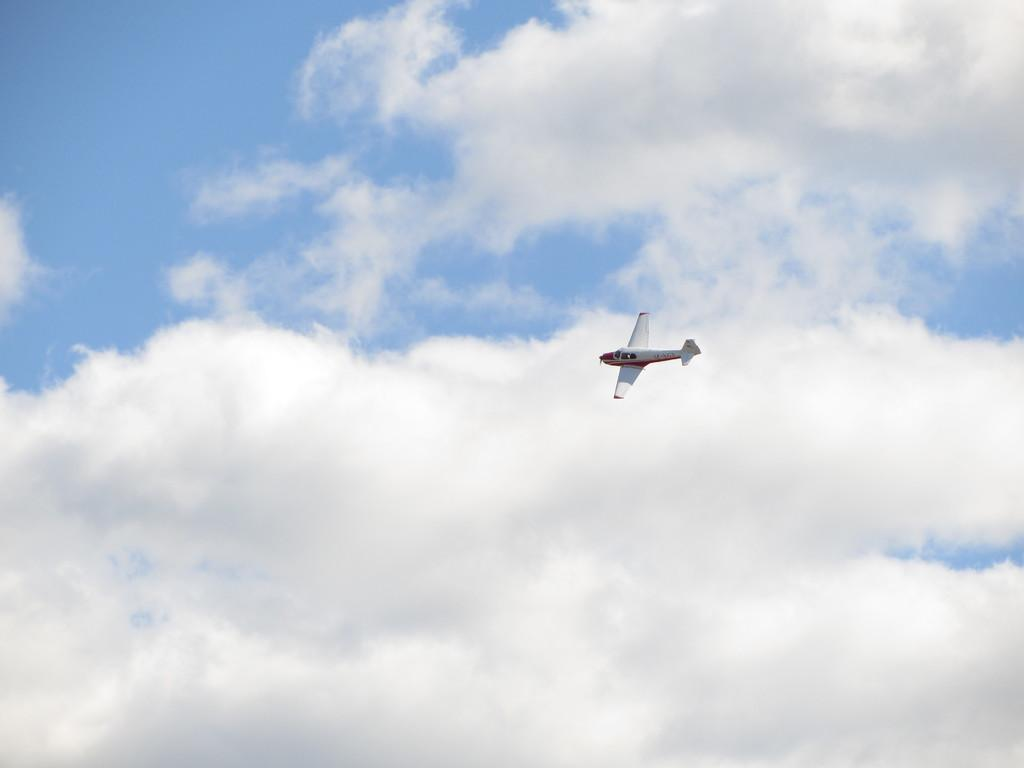Where was the image taken? The image is clicked outside. What can be seen in the sky in the image? There is an airplane flying in the sky. What is visible in the background of the image? The sky is visible in the background of the image. What is the condition of the sky in the image? Clouds are present in the sky. What type of mask is the doll wearing in the image? There is no doll or mask present in the image. 